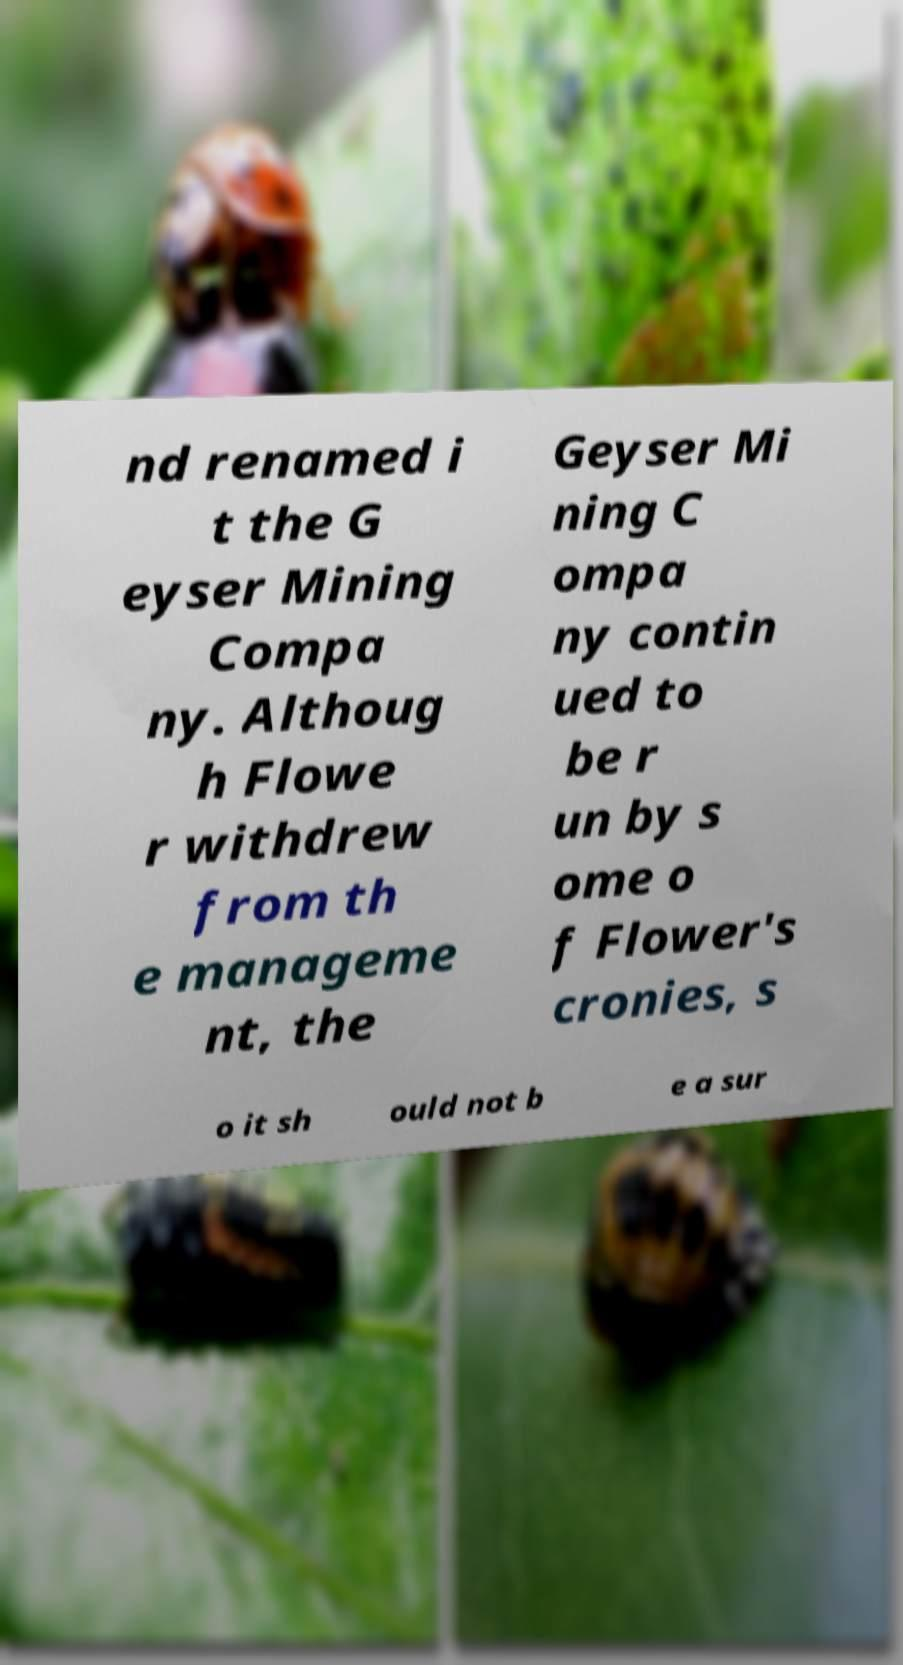Can you read and provide the text displayed in the image?This photo seems to have some interesting text. Can you extract and type it out for me? nd renamed i t the G eyser Mining Compa ny. Althoug h Flowe r withdrew from th e manageme nt, the Geyser Mi ning C ompa ny contin ued to be r un by s ome o f Flower's cronies, s o it sh ould not b e a sur 